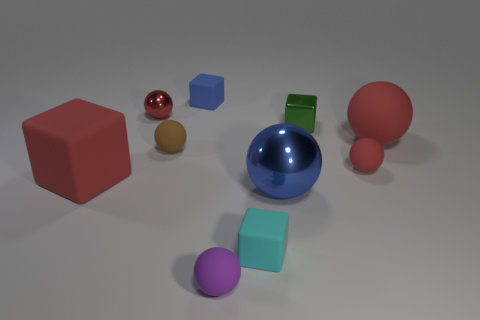Do the blue block and the tiny green cube right of the tiny blue rubber thing have the same material?
Make the answer very short. No. There is a blue metallic object that is the same shape as the brown matte thing; what is its size?
Keep it short and to the point. Large. What material is the tiny blue object?
Provide a succinct answer. Rubber. There is a small cube in front of the shiny sphere on the right side of the rubber block to the right of the blue matte cube; what is its material?
Offer a very short reply. Rubber. There is a matte cube that is to the right of the purple sphere; is its size the same as the rubber thing that is in front of the tiny cyan matte object?
Keep it short and to the point. Yes. How many other things are made of the same material as the green object?
Ensure brevity in your answer.  2. How many metallic objects are red objects or small green cubes?
Your answer should be compact. 2. Is the number of tiny red shiny spheres less than the number of big yellow cubes?
Offer a terse response. No. There is a brown ball; does it have the same size as the shiny ball on the right side of the red shiny sphere?
Keep it short and to the point. No. Is there anything else that is the same shape as the small blue thing?
Make the answer very short. Yes. 